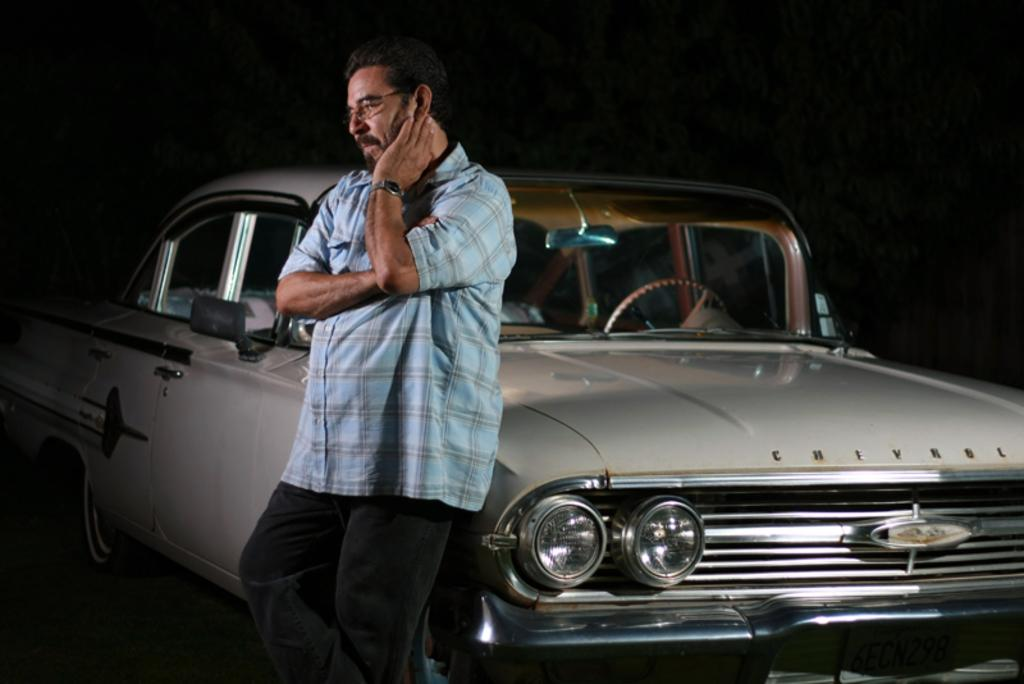What is the main subject of the image? There is a man standing in the image. What can be seen on the right side of the man? A: There is a car on the right side of the man. How would you describe the background of the image? The background of the image is dark. What type of pig can be seen driving the car in the image? There is no pig present in the image, let alone driving a car. 